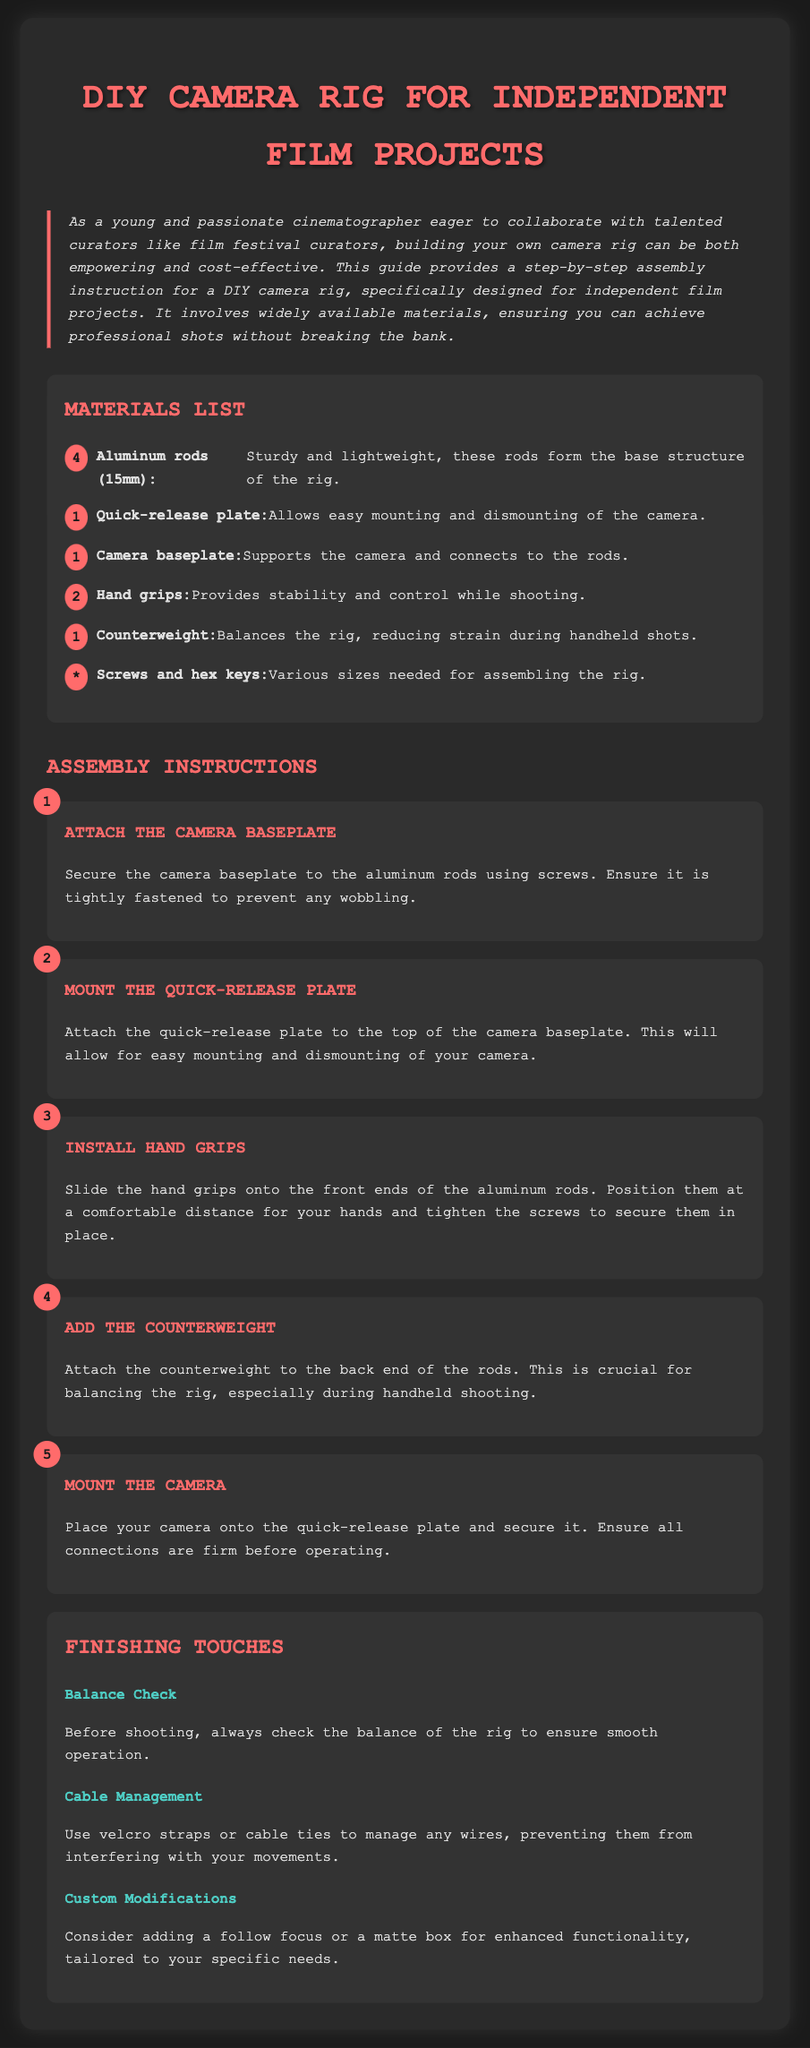What is the main purpose of this document? The document provides assembly instructions for building a DIY camera rig for independent film projects.
Answer: assembly instructions for building a DIY camera rig How many aluminum rods are needed? The materials list specifies the number of aluminum rods required for the rig.
Answer: 4 What type of plate is mentioned for easy camera mounting? The document indicates a specific type of plate that facilitates quick mounting of the camera.
Answer: Quick-release plate What should be attached to the back end of the rods? The assembly instructions detail an important component that provides balance to the rig.
Answer: Counterweight What is the first step in the assembly process? The steps outline the order in which parts should be secured when constructing the rig.
Answer: Attach the Camera Baseplate What is recommended for managing wires? The tips section suggests a method to keep cables organized and prevent interference.
Answer: velcro straps Which grips are to be installed for stability? The assembly instructions specify an object that is crucial for hand control while using the rig.
Answer: Hand grips What is a suggested modification for enhanced functionality? The finishing touches include advice on how to customize the rig for better usability based on specific needs.
Answer: follow focus How many hand grips are required? The materials list provides the quantity of specific components needed for assembly.
Answer: 2 